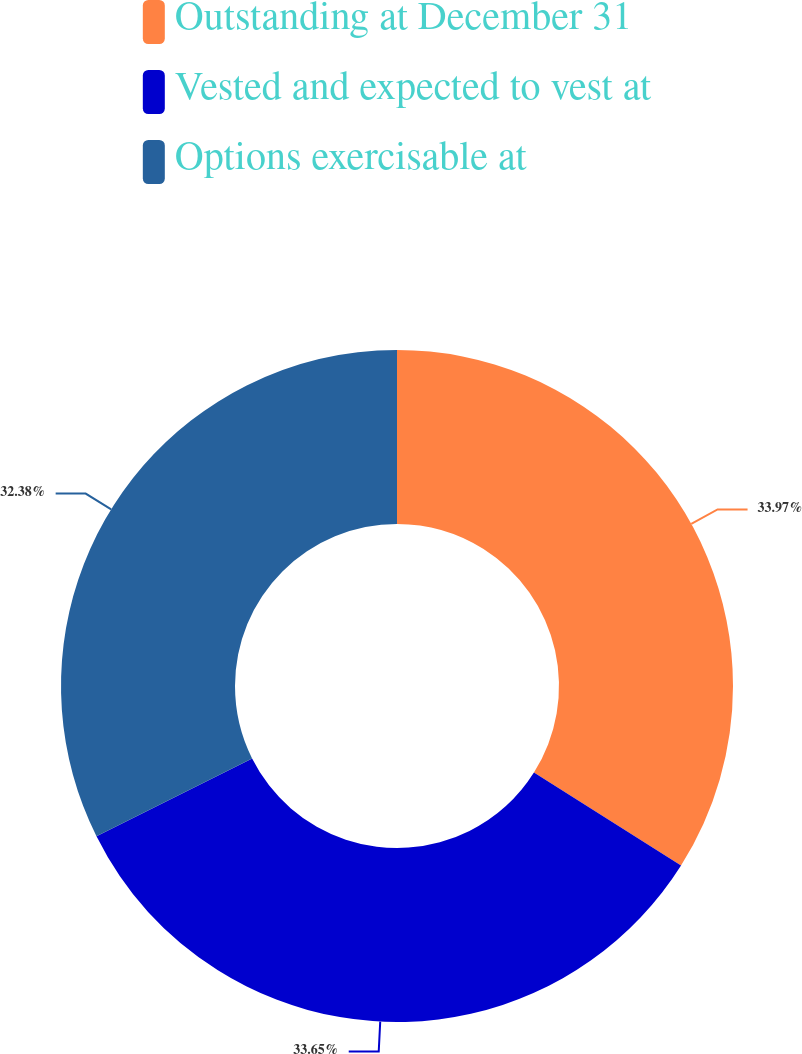Convert chart to OTSL. <chart><loc_0><loc_0><loc_500><loc_500><pie_chart><fcel>Outstanding at December 31<fcel>Vested and expected to vest at<fcel>Options exercisable at<nl><fcel>33.97%<fcel>33.65%<fcel>32.38%<nl></chart> 